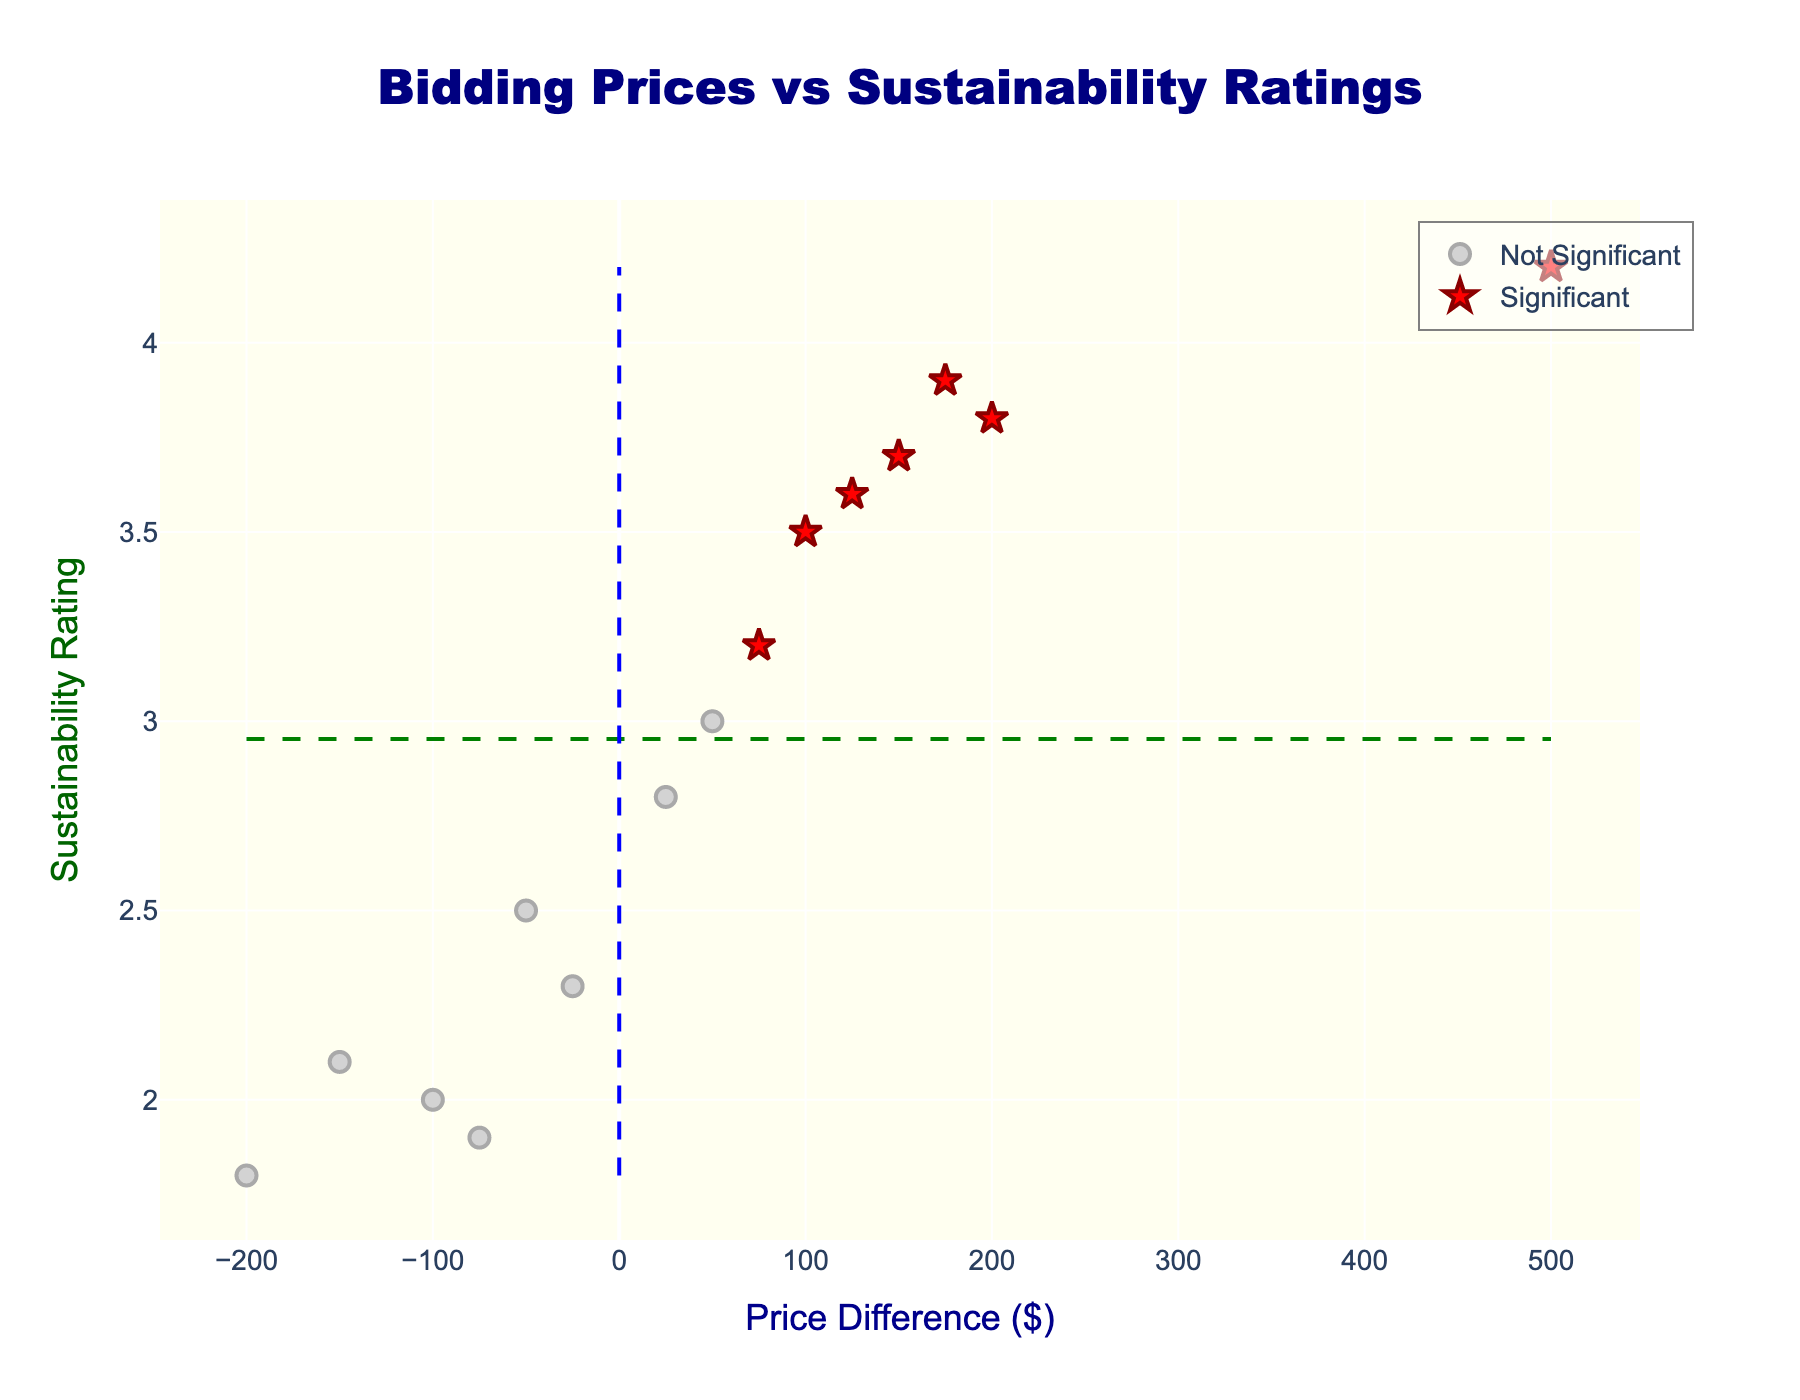What's the title of the plot? The title is usually positioned at the top of the plot. In this case, the title is centered and reads "Bidding Prices vs Sustainability Ratings"
Answer: Bidding Prices vs Sustainability Ratings What do the red star symbols represent? In the plot, the red star symbols are labeled "Significant" in the legend, indicating suppliers that have been identified as significant points.
Answer: Significant suppliers What parameter is measured on the x-axis? The x-axis label reads "Price Difference ($)", suggesting that it measures the price difference in dollars for each supplier.
Answer: Price Difference ($) How many suppliers are marked as significant? The red star symbols represent significant suppliers. Counting them in the plot reveals seven significant suppliers.
Answer: Seven Which supplier has the highest price difference? By observing the x-axis and the red star symbols, you can see that the supplier Apple has the highest price difference, indicated by the farthest red star to the right.
Answer: Apple What is the average sustainability rating, marked by the green dashed line? The green dashed horizontal line represents the average sustainability rating. By finding its value on the y-axis, we see it's around 2.8.
Answer: Around 2.8 Which supplier offers the lowest price difference while still being significant? Among the red star symbols, the one farthest to the left is HP, indicating it's the significant supplier with the lowest price difference.
Answer: HP Compare the sustainability ratings of HP and Apple. Which one is higher? HP and Apple are both marked by red stars. HP has a sustainability rating of 3.8 and Apple has 4.2. Therefore, Apple's sustainability rating is higher.
Answer: Apple Identify a supplier that is not significant and has a sustainability rating close to the average. By looking at the grey markers near the green dashed line of average sustainability rating (2.8), and ensuring it is not a red star, Brother appears to be close with a rating of 2.8.
Answer: Brother 